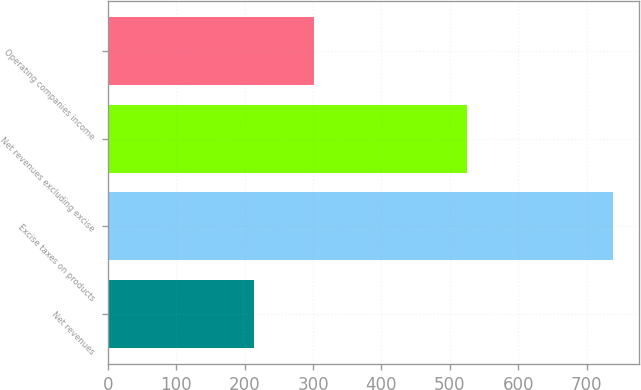<chart> <loc_0><loc_0><loc_500><loc_500><bar_chart><fcel>Net revenues<fcel>Excise taxes on products<fcel>Net revenues excluding excise<fcel>Operating companies income<nl><fcel>214<fcel>739<fcel>525<fcel>301<nl></chart> 